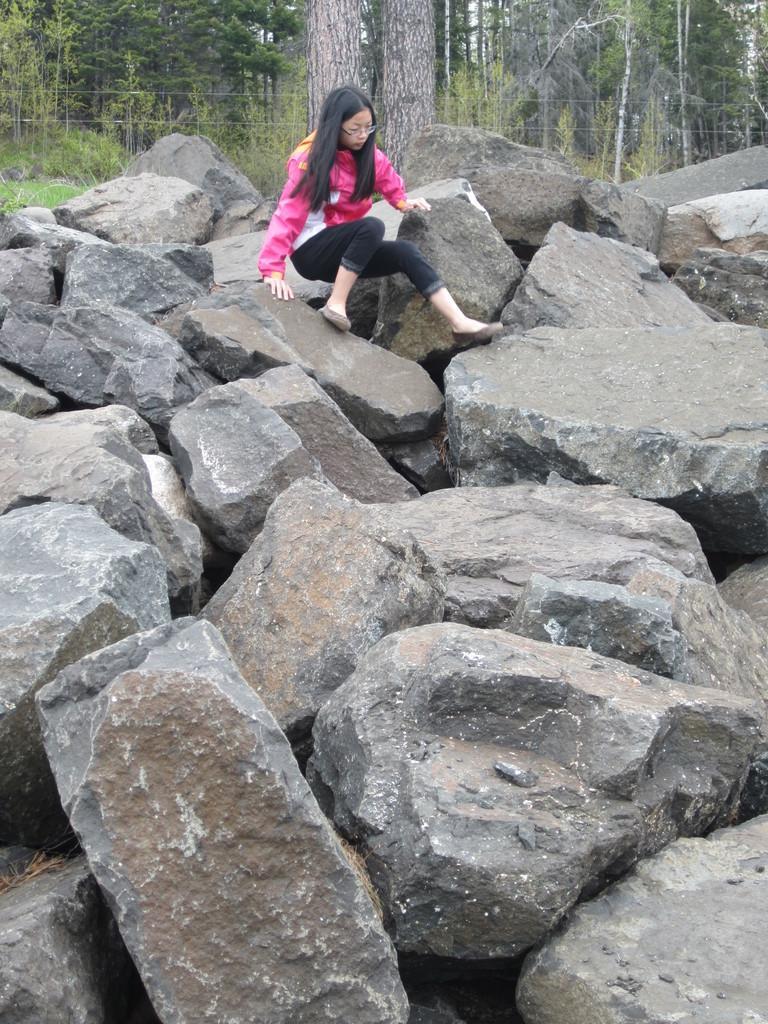Could you give a brief overview of what you see in this image? In this image there are trees truncated towards the top of the image, there are plants, there are plants truncated towards the left of the image, there is grass truncated towards the left of the image, there are rocks, there is a person on the rock, there are rocks truncated towards the right of the image, there are rocks truncated towards the bottom of the image, there are rocks truncated towards the left of the image. 